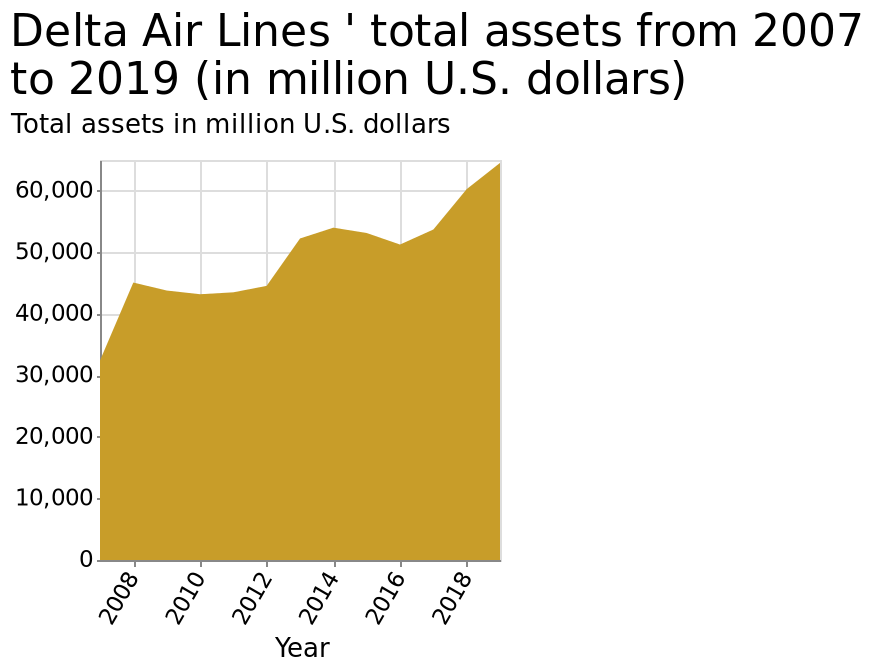<image>
What does the y-axis represent in the area graph?  The y-axis in the area graph represents the total assets of Delta Air Lines in million U.S. dollars. What has been happening to the total assets over the past 10 years?  The total assets have been increasing. please describe the details of the chart Here a area graph is called Delta Air Lines ' total assets from 2007 to 2019 (in million U.S. dollars). The x-axis shows Year along linear scale of range 2008 to 2018 while the y-axis plots Total assets in million U.S. dollars along linear scale with a minimum of 0 and a maximum of 60,000. 